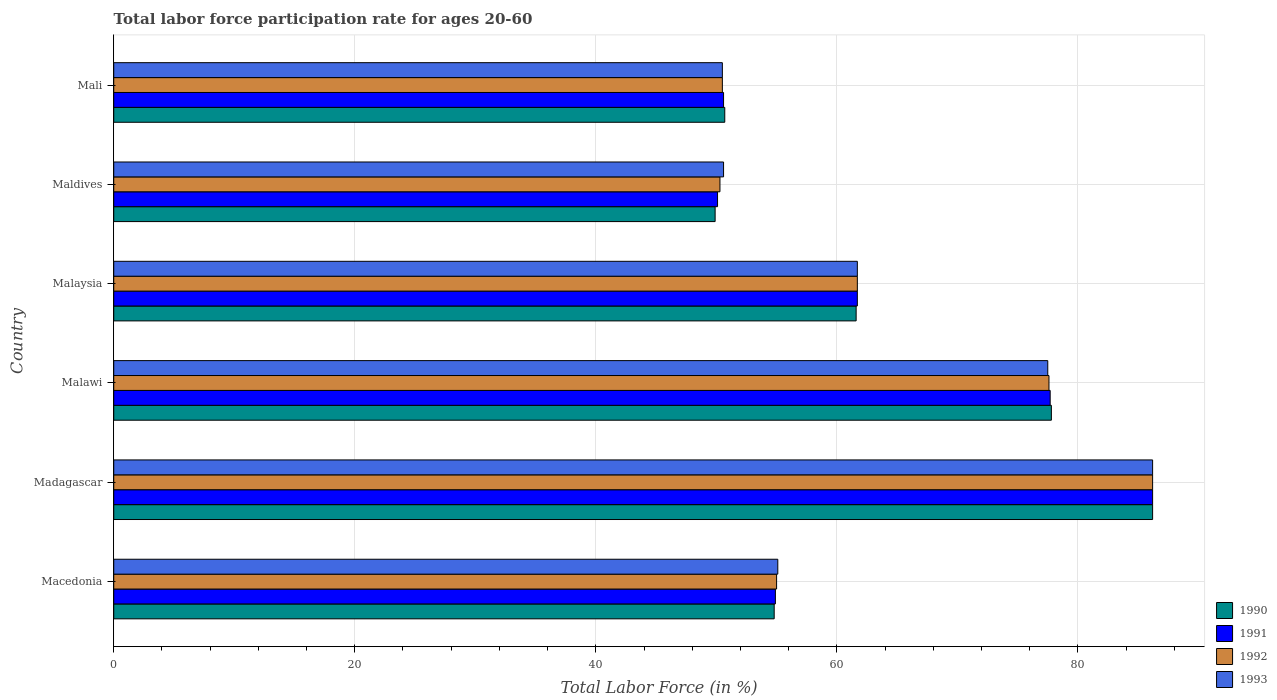How many different coloured bars are there?
Your answer should be very brief. 4. Are the number of bars on each tick of the Y-axis equal?
Ensure brevity in your answer.  Yes. How many bars are there on the 3rd tick from the top?
Provide a succinct answer. 4. What is the label of the 3rd group of bars from the top?
Offer a terse response. Malaysia. In how many cases, is the number of bars for a given country not equal to the number of legend labels?
Keep it short and to the point. 0. What is the labor force participation rate in 1993 in Malawi?
Provide a succinct answer. 77.5. Across all countries, what is the maximum labor force participation rate in 1993?
Ensure brevity in your answer.  86.2. Across all countries, what is the minimum labor force participation rate in 1992?
Keep it short and to the point. 50.3. In which country was the labor force participation rate in 1990 maximum?
Keep it short and to the point. Madagascar. In which country was the labor force participation rate in 1992 minimum?
Ensure brevity in your answer.  Maldives. What is the total labor force participation rate in 1991 in the graph?
Your response must be concise. 381.2. What is the difference between the labor force participation rate in 1993 in Maldives and that in Mali?
Provide a short and direct response. 0.1. What is the difference between the labor force participation rate in 1990 in Macedonia and the labor force participation rate in 1993 in Madagascar?
Your response must be concise. -31.4. What is the average labor force participation rate in 1992 per country?
Your answer should be compact. 63.55. What is the ratio of the labor force participation rate in 1990 in Malawi to that in Malaysia?
Offer a terse response. 1.26. Is the labor force participation rate in 1992 in Malawi less than that in Maldives?
Offer a terse response. No. Is the difference between the labor force participation rate in 1993 in Macedonia and Malaysia greater than the difference between the labor force participation rate in 1990 in Macedonia and Malaysia?
Keep it short and to the point. Yes. What is the difference between the highest and the second highest labor force participation rate in 1990?
Your answer should be compact. 8.4. What is the difference between the highest and the lowest labor force participation rate in 1990?
Offer a very short reply. 36.3. Is the sum of the labor force participation rate in 1993 in Malawi and Maldives greater than the maximum labor force participation rate in 1992 across all countries?
Provide a succinct answer. Yes. Is it the case that in every country, the sum of the labor force participation rate in 1990 and labor force participation rate in 1993 is greater than the sum of labor force participation rate in 1992 and labor force participation rate in 1991?
Your answer should be very brief. No. What does the 4th bar from the bottom in Maldives represents?
Your answer should be compact. 1993. Is it the case that in every country, the sum of the labor force participation rate in 1993 and labor force participation rate in 1990 is greater than the labor force participation rate in 1992?
Your response must be concise. Yes. How many bars are there?
Provide a succinct answer. 24. Are all the bars in the graph horizontal?
Make the answer very short. Yes. Does the graph contain grids?
Make the answer very short. Yes. Where does the legend appear in the graph?
Offer a very short reply. Bottom right. How many legend labels are there?
Your answer should be compact. 4. What is the title of the graph?
Offer a terse response. Total labor force participation rate for ages 20-60. What is the label or title of the X-axis?
Provide a short and direct response. Total Labor Force (in %). What is the label or title of the Y-axis?
Ensure brevity in your answer.  Country. What is the Total Labor Force (in %) of 1990 in Macedonia?
Ensure brevity in your answer.  54.8. What is the Total Labor Force (in %) of 1991 in Macedonia?
Provide a short and direct response. 54.9. What is the Total Labor Force (in %) in 1992 in Macedonia?
Your answer should be very brief. 55. What is the Total Labor Force (in %) in 1993 in Macedonia?
Your answer should be very brief. 55.1. What is the Total Labor Force (in %) of 1990 in Madagascar?
Your answer should be very brief. 86.2. What is the Total Labor Force (in %) in 1991 in Madagascar?
Offer a terse response. 86.2. What is the Total Labor Force (in %) of 1992 in Madagascar?
Your answer should be compact. 86.2. What is the Total Labor Force (in %) in 1993 in Madagascar?
Give a very brief answer. 86.2. What is the Total Labor Force (in %) in 1990 in Malawi?
Ensure brevity in your answer.  77.8. What is the Total Labor Force (in %) of 1991 in Malawi?
Ensure brevity in your answer.  77.7. What is the Total Labor Force (in %) of 1992 in Malawi?
Ensure brevity in your answer.  77.6. What is the Total Labor Force (in %) in 1993 in Malawi?
Provide a succinct answer. 77.5. What is the Total Labor Force (in %) in 1990 in Malaysia?
Provide a succinct answer. 61.6. What is the Total Labor Force (in %) in 1991 in Malaysia?
Offer a terse response. 61.7. What is the Total Labor Force (in %) of 1992 in Malaysia?
Ensure brevity in your answer.  61.7. What is the Total Labor Force (in %) of 1993 in Malaysia?
Offer a terse response. 61.7. What is the Total Labor Force (in %) of 1990 in Maldives?
Your answer should be compact. 49.9. What is the Total Labor Force (in %) in 1991 in Maldives?
Offer a very short reply. 50.1. What is the Total Labor Force (in %) of 1992 in Maldives?
Make the answer very short. 50.3. What is the Total Labor Force (in %) in 1993 in Maldives?
Your response must be concise. 50.6. What is the Total Labor Force (in %) in 1990 in Mali?
Provide a short and direct response. 50.7. What is the Total Labor Force (in %) in 1991 in Mali?
Provide a short and direct response. 50.6. What is the Total Labor Force (in %) in 1992 in Mali?
Provide a short and direct response. 50.5. What is the Total Labor Force (in %) of 1993 in Mali?
Your answer should be very brief. 50.5. Across all countries, what is the maximum Total Labor Force (in %) in 1990?
Provide a short and direct response. 86.2. Across all countries, what is the maximum Total Labor Force (in %) in 1991?
Make the answer very short. 86.2. Across all countries, what is the maximum Total Labor Force (in %) of 1992?
Offer a terse response. 86.2. Across all countries, what is the maximum Total Labor Force (in %) in 1993?
Give a very brief answer. 86.2. Across all countries, what is the minimum Total Labor Force (in %) of 1990?
Provide a short and direct response. 49.9. Across all countries, what is the minimum Total Labor Force (in %) in 1991?
Keep it short and to the point. 50.1. Across all countries, what is the minimum Total Labor Force (in %) in 1992?
Offer a very short reply. 50.3. Across all countries, what is the minimum Total Labor Force (in %) in 1993?
Give a very brief answer. 50.5. What is the total Total Labor Force (in %) of 1990 in the graph?
Your response must be concise. 381. What is the total Total Labor Force (in %) of 1991 in the graph?
Keep it short and to the point. 381.2. What is the total Total Labor Force (in %) in 1992 in the graph?
Provide a short and direct response. 381.3. What is the total Total Labor Force (in %) in 1993 in the graph?
Provide a short and direct response. 381.6. What is the difference between the Total Labor Force (in %) in 1990 in Macedonia and that in Madagascar?
Provide a succinct answer. -31.4. What is the difference between the Total Labor Force (in %) in 1991 in Macedonia and that in Madagascar?
Offer a very short reply. -31.3. What is the difference between the Total Labor Force (in %) of 1992 in Macedonia and that in Madagascar?
Your answer should be compact. -31.2. What is the difference between the Total Labor Force (in %) in 1993 in Macedonia and that in Madagascar?
Your response must be concise. -31.1. What is the difference between the Total Labor Force (in %) in 1991 in Macedonia and that in Malawi?
Provide a short and direct response. -22.8. What is the difference between the Total Labor Force (in %) of 1992 in Macedonia and that in Malawi?
Keep it short and to the point. -22.6. What is the difference between the Total Labor Force (in %) of 1993 in Macedonia and that in Malawi?
Keep it short and to the point. -22.4. What is the difference between the Total Labor Force (in %) in 1990 in Macedonia and that in Malaysia?
Offer a terse response. -6.8. What is the difference between the Total Labor Force (in %) of 1993 in Macedonia and that in Malaysia?
Your response must be concise. -6.6. What is the difference between the Total Labor Force (in %) in 1992 in Macedonia and that in Maldives?
Your answer should be very brief. 4.7. What is the difference between the Total Labor Force (in %) in 1993 in Macedonia and that in Maldives?
Give a very brief answer. 4.5. What is the difference between the Total Labor Force (in %) in 1992 in Madagascar and that in Malawi?
Your response must be concise. 8.6. What is the difference between the Total Labor Force (in %) of 1990 in Madagascar and that in Malaysia?
Offer a very short reply. 24.6. What is the difference between the Total Labor Force (in %) of 1992 in Madagascar and that in Malaysia?
Offer a terse response. 24.5. What is the difference between the Total Labor Force (in %) in 1990 in Madagascar and that in Maldives?
Ensure brevity in your answer.  36.3. What is the difference between the Total Labor Force (in %) in 1991 in Madagascar and that in Maldives?
Keep it short and to the point. 36.1. What is the difference between the Total Labor Force (in %) of 1992 in Madagascar and that in Maldives?
Provide a succinct answer. 35.9. What is the difference between the Total Labor Force (in %) in 1993 in Madagascar and that in Maldives?
Make the answer very short. 35.6. What is the difference between the Total Labor Force (in %) in 1990 in Madagascar and that in Mali?
Your answer should be very brief. 35.5. What is the difference between the Total Labor Force (in %) in 1991 in Madagascar and that in Mali?
Your answer should be compact. 35.6. What is the difference between the Total Labor Force (in %) of 1992 in Madagascar and that in Mali?
Keep it short and to the point. 35.7. What is the difference between the Total Labor Force (in %) in 1993 in Madagascar and that in Mali?
Your answer should be compact. 35.7. What is the difference between the Total Labor Force (in %) in 1991 in Malawi and that in Malaysia?
Keep it short and to the point. 16. What is the difference between the Total Labor Force (in %) in 1993 in Malawi and that in Malaysia?
Offer a very short reply. 15.8. What is the difference between the Total Labor Force (in %) of 1990 in Malawi and that in Maldives?
Ensure brevity in your answer.  27.9. What is the difference between the Total Labor Force (in %) of 1991 in Malawi and that in Maldives?
Give a very brief answer. 27.6. What is the difference between the Total Labor Force (in %) of 1992 in Malawi and that in Maldives?
Your answer should be compact. 27.3. What is the difference between the Total Labor Force (in %) in 1993 in Malawi and that in Maldives?
Offer a very short reply. 26.9. What is the difference between the Total Labor Force (in %) of 1990 in Malawi and that in Mali?
Your answer should be compact. 27.1. What is the difference between the Total Labor Force (in %) of 1991 in Malawi and that in Mali?
Provide a short and direct response. 27.1. What is the difference between the Total Labor Force (in %) in 1992 in Malawi and that in Mali?
Keep it short and to the point. 27.1. What is the difference between the Total Labor Force (in %) of 1993 in Malawi and that in Mali?
Offer a very short reply. 27. What is the difference between the Total Labor Force (in %) in 1991 in Malaysia and that in Maldives?
Make the answer very short. 11.6. What is the difference between the Total Labor Force (in %) in 1992 in Malaysia and that in Maldives?
Make the answer very short. 11.4. What is the difference between the Total Labor Force (in %) of 1993 in Malaysia and that in Maldives?
Offer a very short reply. 11.1. What is the difference between the Total Labor Force (in %) in 1990 in Malaysia and that in Mali?
Your response must be concise. 10.9. What is the difference between the Total Labor Force (in %) in 1990 in Maldives and that in Mali?
Offer a terse response. -0.8. What is the difference between the Total Labor Force (in %) of 1992 in Maldives and that in Mali?
Provide a short and direct response. -0.2. What is the difference between the Total Labor Force (in %) of 1990 in Macedonia and the Total Labor Force (in %) of 1991 in Madagascar?
Offer a very short reply. -31.4. What is the difference between the Total Labor Force (in %) of 1990 in Macedonia and the Total Labor Force (in %) of 1992 in Madagascar?
Ensure brevity in your answer.  -31.4. What is the difference between the Total Labor Force (in %) in 1990 in Macedonia and the Total Labor Force (in %) in 1993 in Madagascar?
Give a very brief answer. -31.4. What is the difference between the Total Labor Force (in %) of 1991 in Macedonia and the Total Labor Force (in %) of 1992 in Madagascar?
Give a very brief answer. -31.3. What is the difference between the Total Labor Force (in %) of 1991 in Macedonia and the Total Labor Force (in %) of 1993 in Madagascar?
Make the answer very short. -31.3. What is the difference between the Total Labor Force (in %) in 1992 in Macedonia and the Total Labor Force (in %) in 1993 in Madagascar?
Your answer should be very brief. -31.2. What is the difference between the Total Labor Force (in %) in 1990 in Macedonia and the Total Labor Force (in %) in 1991 in Malawi?
Give a very brief answer. -22.9. What is the difference between the Total Labor Force (in %) of 1990 in Macedonia and the Total Labor Force (in %) of 1992 in Malawi?
Your answer should be very brief. -22.8. What is the difference between the Total Labor Force (in %) in 1990 in Macedonia and the Total Labor Force (in %) in 1993 in Malawi?
Your answer should be compact. -22.7. What is the difference between the Total Labor Force (in %) of 1991 in Macedonia and the Total Labor Force (in %) of 1992 in Malawi?
Your response must be concise. -22.7. What is the difference between the Total Labor Force (in %) of 1991 in Macedonia and the Total Labor Force (in %) of 1993 in Malawi?
Offer a very short reply. -22.6. What is the difference between the Total Labor Force (in %) in 1992 in Macedonia and the Total Labor Force (in %) in 1993 in Malawi?
Your response must be concise. -22.5. What is the difference between the Total Labor Force (in %) of 1990 in Macedonia and the Total Labor Force (in %) of 1992 in Malaysia?
Offer a terse response. -6.9. What is the difference between the Total Labor Force (in %) of 1990 in Macedonia and the Total Labor Force (in %) of 1993 in Malaysia?
Keep it short and to the point. -6.9. What is the difference between the Total Labor Force (in %) of 1992 in Macedonia and the Total Labor Force (in %) of 1993 in Malaysia?
Your answer should be very brief. -6.7. What is the difference between the Total Labor Force (in %) in 1990 in Macedonia and the Total Labor Force (in %) in 1991 in Maldives?
Provide a short and direct response. 4.7. What is the difference between the Total Labor Force (in %) in 1991 in Macedonia and the Total Labor Force (in %) in 1992 in Maldives?
Your answer should be very brief. 4.6. What is the difference between the Total Labor Force (in %) of 1991 in Macedonia and the Total Labor Force (in %) of 1993 in Maldives?
Your response must be concise. 4.3. What is the difference between the Total Labor Force (in %) in 1990 in Macedonia and the Total Labor Force (in %) in 1992 in Mali?
Offer a very short reply. 4.3. What is the difference between the Total Labor Force (in %) in 1990 in Macedonia and the Total Labor Force (in %) in 1993 in Mali?
Offer a terse response. 4.3. What is the difference between the Total Labor Force (in %) of 1992 in Macedonia and the Total Labor Force (in %) of 1993 in Mali?
Make the answer very short. 4.5. What is the difference between the Total Labor Force (in %) of 1990 in Madagascar and the Total Labor Force (in %) of 1992 in Malawi?
Provide a succinct answer. 8.6. What is the difference between the Total Labor Force (in %) of 1990 in Madagascar and the Total Labor Force (in %) of 1993 in Malawi?
Your answer should be very brief. 8.7. What is the difference between the Total Labor Force (in %) of 1992 in Madagascar and the Total Labor Force (in %) of 1993 in Malawi?
Give a very brief answer. 8.7. What is the difference between the Total Labor Force (in %) of 1990 in Madagascar and the Total Labor Force (in %) of 1992 in Malaysia?
Ensure brevity in your answer.  24.5. What is the difference between the Total Labor Force (in %) in 1991 in Madagascar and the Total Labor Force (in %) in 1993 in Malaysia?
Make the answer very short. 24.5. What is the difference between the Total Labor Force (in %) in 1992 in Madagascar and the Total Labor Force (in %) in 1993 in Malaysia?
Offer a very short reply. 24.5. What is the difference between the Total Labor Force (in %) of 1990 in Madagascar and the Total Labor Force (in %) of 1991 in Maldives?
Provide a short and direct response. 36.1. What is the difference between the Total Labor Force (in %) in 1990 in Madagascar and the Total Labor Force (in %) in 1992 in Maldives?
Keep it short and to the point. 35.9. What is the difference between the Total Labor Force (in %) in 1990 in Madagascar and the Total Labor Force (in %) in 1993 in Maldives?
Your answer should be compact. 35.6. What is the difference between the Total Labor Force (in %) in 1991 in Madagascar and the Total Labor Force (in %) in 1992 in Maldives?
Offer a terse response. 35.9. What is the difference between the Total Labor Force (in %) in 1991 in Madagascar and the Total Labor Force (in %) in 1993 in Maldives?
Your response must be concise. 35.6. What is the difference between the Total Labor Force (in %) of 1992 in Madagascar and the Total Labor Force (in %) of 1993 in Maldives?
Your answer should be very brief. 35.6. What is the difference between the Total Labor Force (in %) in 1990 in Madagascar and the Total Labor Force (in %) in 1991 in Mali?
Ensure brevity in your answer.  35.6. What is the difference between the Total Labor Force (in %) of 1990 in Madagascar and the Total Labor Force (in %) of 1992 in Mali?
Your response must be concise. 35.7. What is the difference between the Total Labor Force (in %) in 1990 in Madagascar and the Total Labor Force (in %) in 1993 in Mali?
Your answer should be compact. 35.7. What is the difference between the Total Labor Force (in %) of 1991 in Madagascar and the Total Labor Force (in %) of 1992 in Mali?
Ensure brevity in your answer.  35.7. What is the difference between the Total Labor Force (in %) of 1991 in Madagascar and the Total Labor Force (in %) of 1993 in Mali?
Provide a short and direct response. 35.7. What is the difference between the Total Labor Force (in %) of 1992 in Madagascar and the Total Labor Force (in %) of 1993 in Mali?
Ensure brevity in your answer.  35.7. What is the difference between the Total Labor Force (in %) in 1990 in Malawi and the Total Labor Force (in %) in 1993 in Malaysia?
Provide a succinct answer. 16.1. What is the difference between the Total Labor Force (in %) of 1991 in Malawi and the Total Labor Force (in %) of 1993 in Malaysia?
Your answer should be very brief. 16. What is the difference between the Total Labor Force (in %) of 1992 in Malawi and the Total Labor Force (in %) of 1993 in Malaysia?
Your answer should be compact. 15.9. What is the difference between the Total Labor Force (in %) in 1990 in Malawi and the Total Labor Force (in %) in 1991 in Maldives?
Your answer should be compact. 27.7. What is the difference between the Total Labor Force (in %) of 1990 in Malawi and the Total Labor Force (in %) of 1992 in Maldives?
Provide a short and direct response. 27.5. What is the difference between the Total Labor Force (in %) of 1990 in Malawi and the Total Labor Force (in %) of 1993 in Maldives?
Ensure brevity in your answer.  27.2. What is the difference between the Total Labor Force (in %) of 1991 in Malawi and the Total Labor Force (in %) of 1992 in Maldives?
Give a very brief answer. 27.4. What is the difference between the Total Labor Force (in %) of 1991 in Malawi and the Total Labor Force (in %) of 1993 in Maldives?
Offer a very short reply. 27.1. What is the difference between the Total Labor Force (in %) in 1992 in Malawi and the Total Labor Force (in %) in 1993 in Maldives?
Keep it short and to the point. 27. What is the difference between the Total Labor Force (in %) in 1990 in Malawi and the Total Labor Force (in %) in 1991 in Mali?
Your response must be concise. 27.2. What is the difference between the Total Labor Force (in %) in 1990 in Malawi and the Total Labor Force (in %) in 1992 in Mali?
Provide a succinct answer. 27.3. What is the difference between the Total Labor Force (in %) in 1990 in Malawi and the Total Labor Force (in %) in 1993 in Mali?
Make the answer very short. 27.3. What is the difference between the Total Labor Force (in %) in 1991 in Malawi and the Total Labor Force (in %) in 1992 in Mali?
Provide a succinct answer. 27.2. What is the difference between the Total Labor Force (in %) in 1991 in Malawi and the Total Labor Force (in %) in 1993 in Mali?
Your answer should be compact. 27.2. What is the difference between the Total Labor Force (in %) of 1992 in Malawi and the Total Labor Force (in %) of 1993 in Mali?
Provide a succinct answer. 27.1. What is the difference between the Total Labor Force (in %) in 1990 in Malaysia and the Total Labor Force (in %) in 1991 in Maldives?
Keep it short and to the point. 11.5. What is the difference between the Total Labor Force (in %) of 1990 in Malaysia and the Total Labor Force (in %) of 1992 in Maldives?
Your answer should be very brief. 11.3. What is the difference between the Total Labor Force (in %) in 1990 in Malaysia and the Total Labor Force (in %) in 1991 in Mali?
Your answer should be very brief. 11. What is the difference between the Total Labor Force (in %) of 1990 in Malaysia and the Total Labor Force (in %) of 1992 in Mali?
Keep it short and to the point. 11.1. What is the difference between the Total Labor Force (in %) in 1992 in Malaysia and the Total Labor Force (in %) in 1993 in Mali?
Give a very brief answer. 11.2. What is the difference between the Total Labor Force (in %) of 1990 in Maldives and the Total Labor Force (in %) of 1991 in Mali?
Your answer should be compact. -0.7. What is the difference between the Total Labor Force (in %) in 1990 in Maldives and the Total Labor Force (in %) in 1993 in Mali?
Provide a short and direct response. -0.6. What is the average Total Labor Force (in %) in 1990 per country?
Ensure brevity in your answer.  63.5. What is the average Total Labor Force (in %) of 1991 per country?
Your answer should be very brief. 63.53. What is the average Total Labor Force (in %) in 1992 per country?
Your answer should be compact. 63.55. What is the average Total Labor Force (in %) of 1993 per country?
Provide a short and direct response. 63.6. What is the difference between the Total Labor Force (in %) of 1990 and Total Labor Force (in %) of 1991 in Macedonia?
Provide a short and direct response. -0.1. What is the difference between the Total Labor Force (in %) of 1990 and Total Labor Force (in %) of 1993 in Macedonia?
Provide a short and direct response. -0.3. What is the difference between the Total Labor Force (in %) of 1991 and Total Labor Force (in %) of 1993 in Macedonia?
Your response must be concise. -0.2. What is the difference between the Total Labor Force (in %) in 1990 and Total Labor Force (in %) in 1991 in Madagascar?
Provide a succinct answer. 0. What is the difference between the Total Labor Force (in %) in 1990 and Total Labor Force (in %) in 1992 in Madagascar?
Keep it short and to the point. 0. What is the difference between the Total Labor Force (in %) of 1992 and Total Labor Force (in %) of 1993 in Madagascar?
Make the answer very short. 0. What is the difference between the Total Labor Force (in %) in 1990 and Total Labor Force (in %) in 1991 in Malawi?
Give a very brief answer. 0.1. What is the difference between the Total Labor Force (in %) in 1990 and Total Labor Force (in %) in 1992 in Malawi?
Give a very brief answer. 0.2. What is the difference between the Total Labor Force (in %) in 1991 and Total Labor Force (in %) in 1992 in Malawi?
Your answer should be very brief. 0.1. What is the difference between the Total Labor Force (in %) in 1992 and Total Labor Force (in %) in 1993 in Malawi?
Your answer should be compact. 0.1. What is the difference between the Total Labor Force (in %) in 1990 and Total Labor Force (in %) in 1992 in Malaysia?
Provide a short and direct response. -0.1. What is the difference between the Total Labor Force (in %) in 1991 and Total Labor Force (in %) in 1993 in Malaysia?
Offer a very short reply. 0. What is the difference between the Total Labor Force (in %) of 1992 and Total Labor Force (in %) of 1993 in Malaysia?
Your answer should be very brief. 0. What is the difference between the Total Labor Force (in %) in 1990 and Total Labor Force (in %) in 1991 in Maldives?
Provide a succinct answer. -0.2. What is the difference between the Total Labor Force (in %) of 1990 and Total Labor Force (in %) of 1993 in Maldives?
Keep it short and to the point. -0.7. What is the difference between the Total Labor Force (in %) of 1991 and Total Labor Force (in %) of 1992 in Maldives?
Your answer should be very brief. -0.2. What is the difference between the Total Labor Force (in %) in 1990 and Total Labor Force (in %) in 1991 in Mali?
Offer a terse response. 0.1. What is the difference between the Total Labor Force (in %) of 1990 and Total Labor Force (in %) of 1993 in Mali?
Offer a very short reply. 0.2. What is the difference between the Total Labor Force (in %) of 1991 and Total Labor Force (in %) of 1993 in Mali?
Your answer should be very brief. 0.1. What is the difference between the Total Labor Force (in %) of 1992 and Total Labor Force (in %) of 1993 in Mali?
Provide a short and direct response. 0. What is the ratio of the Total Labor Force (in %) in 1990 in Macedonia to that in Madagascar?
Your answer should be compact. 0.64. What is the ratio of the Total Labor Force (in %) of 1991 in Macedonia to that in Madagascar?
Your response must be concise. 0.64. What is the ratio of the Total Labor Force (in %) of 1992 in Macedonia to that in Madagascar?
Your answer should be very brief. 0.64. What is the ratio of the Total Labor Force (in %) of 1993 in Macedonia to that in Madagascar?
Offer a very short reply. 0.64. What is the ratio of the Total Labor Force (in %) in 1990 in Macedonia to that in Malawi?
Offer a terse response. 0.7. What is the ratio of the Total Labor Force (in %) in 1991 in Macedonia to that in Malawi?
Offer a very short reply. 0.71. What is the ratio of the Total Labor Force (in %) in 1992 in Macedonia to that in Malawi?
Ensure brevity in your answer.  0.71. What is the ratio of the Total Labor Force (in %) in 1993 in Macedonia to that in Malawi?
Offer a terse response. 0.71. What is the ratio of the Total Labor Force (in %) in 1990 in Macedonia to that in Malaysia?
Provide a short and direct response. 0.89. What is the ratio of the Total Labor Force (in %) in 1991 in Macedonia to that in Malaysia?
Provide a short and direct response. 0.89. What is the ratio of the Total Labor Force (in %) in 1992 in Macedonia to that in Malaysia?
Keep it short and to the point. 0.89. What is the ratio of the Total Labor Force (in %) of 1993 in Macedonia to that in Malaysia?
Provide a succinct answer. 0.89. What is the ratio of the Total Labor Force (in %) of 1990 in Macedonia to that in Maldives?
Provide a succinct answer. 1.1. What is the ratio of the Total Labor Force (in %) in 1991 in Macedonia to that in Maldives?
Keep it short and to the point. 1.1. What is the ratio of the Total Labor Force (in %) of 1992 in Macedonia to that in Maldives?
Offer a terse response. 1.09. What is the ratio of the Total Labor Force (in %) in 1993 in Macedonia to that in Maldives?
Give a very brief answer. 1.09. What is the ratio of the Total Labor Force (in %) in 1990 in Macedonia to that in Mali?
Your answer should be compact. 1.08. What is the ratio of the Total Labor Force (in %) in 1991 in Macedonia to that in Mali?
Make the answer very short. 1.08. What is the ratio of the Total Labor Force (in %) in 1992 in Macedonia to that in Mali?
Your response must be concise. 1.09. What is the ratio of the Total Labor Force (in %) of 1993 in Macedonia to that in Mali?
Keep it short and to the point. 1.09. What is the ratio of the Total Labor Force (in %) in 1990 in Madagascar to that in Malawi?
Make the answer very short. 1.11. What is the ratio of the Total Labor Force (in %) in 1991 in Madagascar to that in Malawi?
Your answer should be very brief. 1.11. What is the ratio of the Total Labor Force (in %) in 1992 in Madagascar to that in Malawi?
Keep it short and to the point. 1.11. What is the ratio of the Total Labor Force (in %) in 1993 in Madagascar to that in Malawi?
Ensure brevity in your answer.  1.11. What is the ratio of the Total Labor Force (in %) of 1990 in Madagascar to that in Malaysia?
Make the answer very short. 1.4. What is the ratio of the Total Labor Force (in %) in 1991 in Madagascar to that in Malaysia?
Give a very brief answer. 1.4. What is the ratio of the Total Labor Force (in %) in 1992 in Madagascar to that in Malaysia?
Provide a succinct answer. 1.4. What is the ratio of the Total Labor Force (in %) of 1993 in Madagascar to that in Malaysia?
Your response must be concise. 1.4. What is the ratio of the Total Labor Force (in %) in 1990 in Madagascar to that in Maldives?
Make the answer very short. 1.73. What is the ratio of the Total Labor Force (in %) in 1991 in Madagascar to that in Maldives?
Provide a succinct answer. 1.72. What is the ratio of the Total Labor Force (in %) of 1992 in Madagascar to that in Maldives?
Give a very brief answer. 1.71. What is the ratio of the Total Labor Force (in %) in 1993 in Madagascar to that in Maldives?
Your answer should be very brief. 1.7. What is the ratio of the Total Labor Force (in %) of 1990 in Madagascar to that in Mali?
Give a very brief answer. 1.7. What is the ratio of the Total Labor Force (in %) in 1991 in Madagascar to that in Mali?
Offer a terse response. 1.7. What is the ratio of the Total Labor Force (in %) in 1992 in Madagascar to that in Mali?
Provide a short and direct response. 1.71. What is the ratio of the Total Labor Force (in %) of 1993 in Madagascar to that in Mali?
Your response must be concise. 1.71. What is the ratio of the Total Labor Force (in %) of 1990 in Malawi to that in Malaysia?
Ensure brevity in your answer.  1.26. What is the ratio of the Total Labor Force (in %) in 1991 in Malawi to that in Malaysia?
Your response must be concise. 1.26. What is the ratio of the Total Labor Force (in %) of 1992 in Malawi to that in Malaysia?
Provide a short and direct response. 1.26. What is the ratio of the Total Labor Force (in %) of 1993 in Malawi to that in Malaysia?
Your response must be concise. 1.26. What is the ratio of the Total Labor Force (in %) of 1990 in Malawi to that in Maldives?
Your answer should be compact. 1.56. What is the ratio of the Total Labor Force (in %) in 1991 in Malawi to that in Maldives?
Your answer should be very brief. 1.55. What is the ratio of the Total Labor Force (in %) in 1992 in Malawi to that in Maldives?
Offer a very short reply. 1.54. What is the ratio of the Total Labor Force (in %) of 1993 in Malawi to that in Maldives?
Ensure brevity in your answer.  1.53. What is the ratio of the Total Labor Force (in %) of 1990 in Malawi to that in Mali?
Keep it short and to the point. 1.53. What is the ratio of the Total Labor Force (in %) of 1991 in Malawi to that in Mali?
Provide a succinct answer. 1.54. What is the ratio of the Total Labor Force (in %) of 1992 in Malawi to that in Mali?
Your answer should be very brief. 1.54. What is the ratio of the Total Labor Force (in %) in 1993 in Malawi to that in Mali?
Your response must be concise. 1.53. What is the ratio of the Total Labor Force (in %) in 1990 in Malaysia to that in Maldives?
Your answer should be compact. 1.23. What is the ratio of the Total Labor Force (in %) of 1991 in Malaysia to that in Maldives?
Offer a very short reply. 1.23. What is the ratio of the Total Labor Force (in %) of 1992 in Malaysia to that in Maldives?
Give a very brief answer. 1.23. What is the ratio of the Total Labor Force (in %) in 1993 in Malaysia to that in Maldives?
Keep it short and to the point. 1.22. What is the ratio of the Total Labor Force (in %) of 1990 in Malaysia to that in Mali?
Offer a terse response. 1.22. What is the ratio of the Total Labor Force (in %) of 1991 in Malaysia to that in Mali?
Ensure brevity in your answer.  1.22. What is the ratio of the Total Labor Force (in %) in 1992 in Malaysia to that in Mali?
Offer a very short reply. 1.22. What is the ratio of the Total Labor Force (in %) in 1993 in Malaysia to that in Mali?
Offer a terse response. 1.22. What is the ratio of the Total Labor Force (in %) in 1990 in Maldives to that in Mali?
Your answer should be compact. 0.98. What is the ratio of the Total Labor Force (in %) in 1992 in Maldives to that in Mali?
Provide a short and direct response. 1. What is the ratio of the Total Labor Force (in %) in 1993 in Maldives to that in Mali?
Provide a succinct answer. 1. What is the difference between the highest and the lowest Total Labor Force (in %) in 1990?
Give a very brief answer. 36.3. What is the difference between the highest and the lowest Total Labor Force (in %) in 1991?
Keep it short and to the point. 36.1. What is the difference between the highest and the lowest Total Labor Force (in %) in 1992?
Keep it short and to the point. 35.9. What is the difference between the highest and the lowest Total Labor Force (in %) of 1993?
Ensure brevity in your answer.  35.7. 